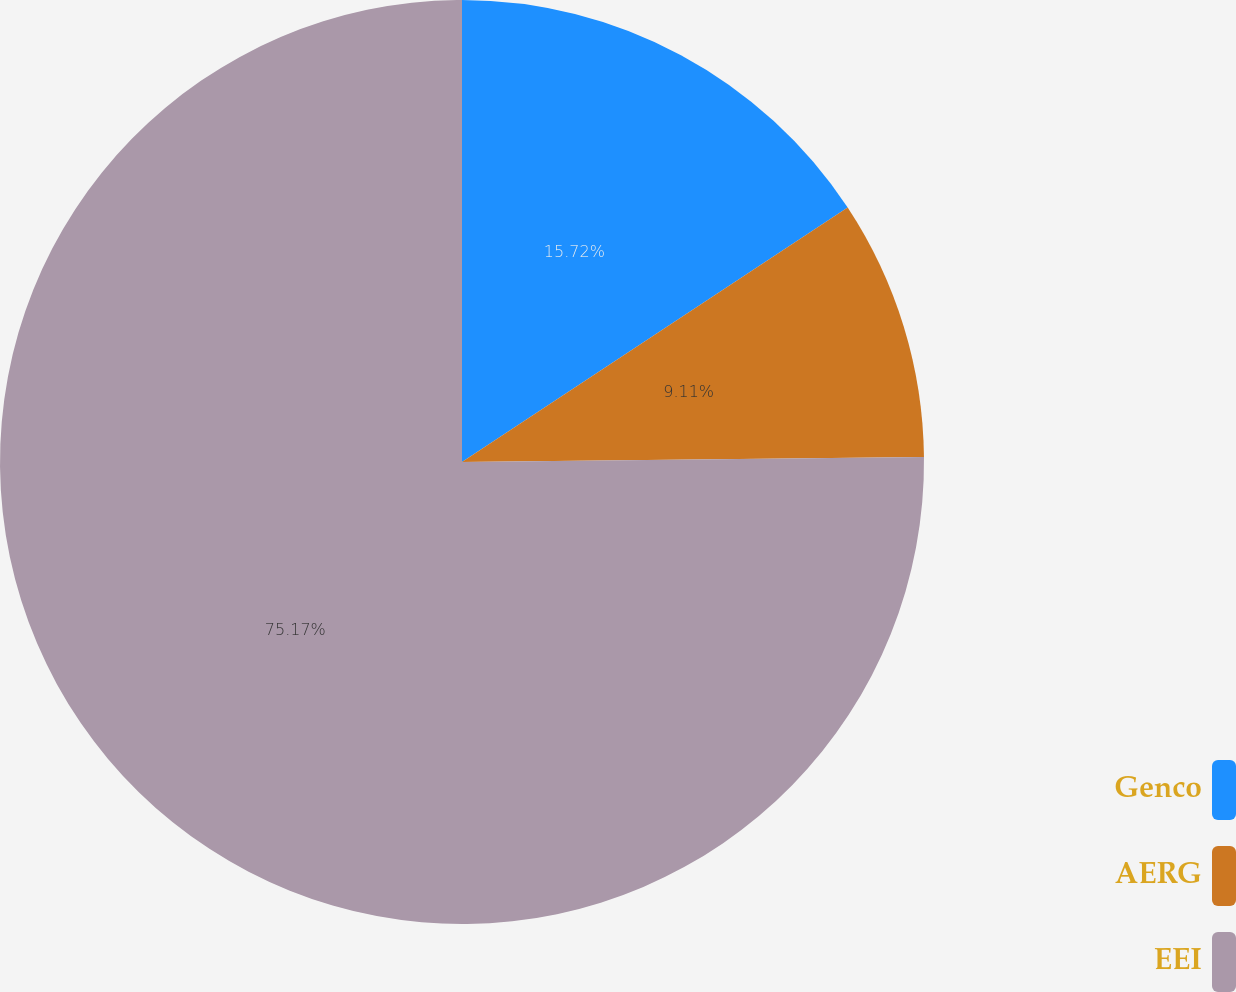<chart> <loc_0><loc_0><loc_500><loc_500><pie_chart><fcel>Genco<fcel>AERG<fcel>EEI<nl><fcel>15.72%<fcel>9.11%<fcel>75.17%<nl></chart> 